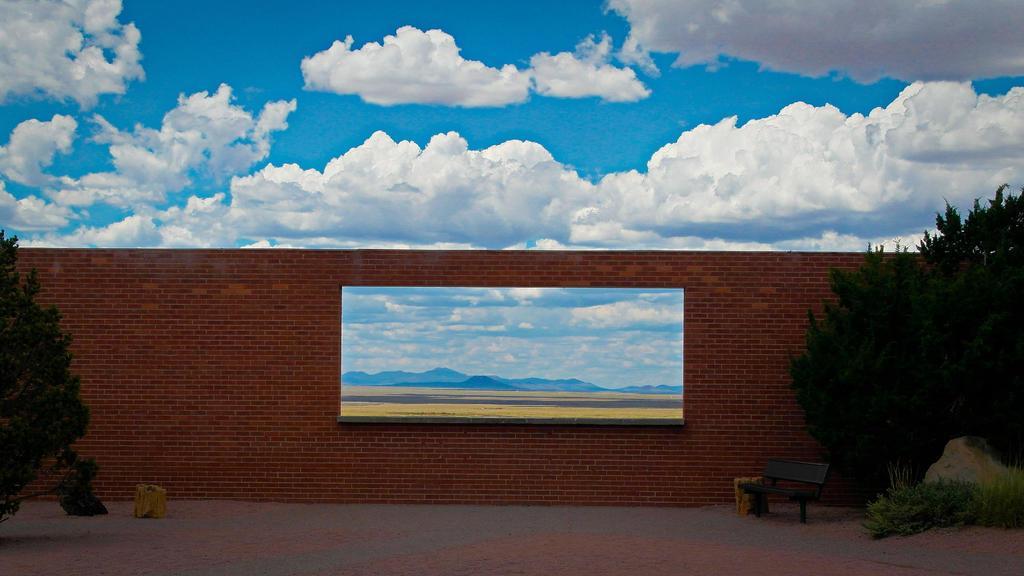How would you summarize this image in a sentence or two? This image is an animated image. At the top of the image there is a sky with clouds. At the bottom of the image there is a ground. In the middle of the image there is a wall with a hole and through the hole we can see there are few hills in the background. On the left and right sides of the image there are a few plants. 